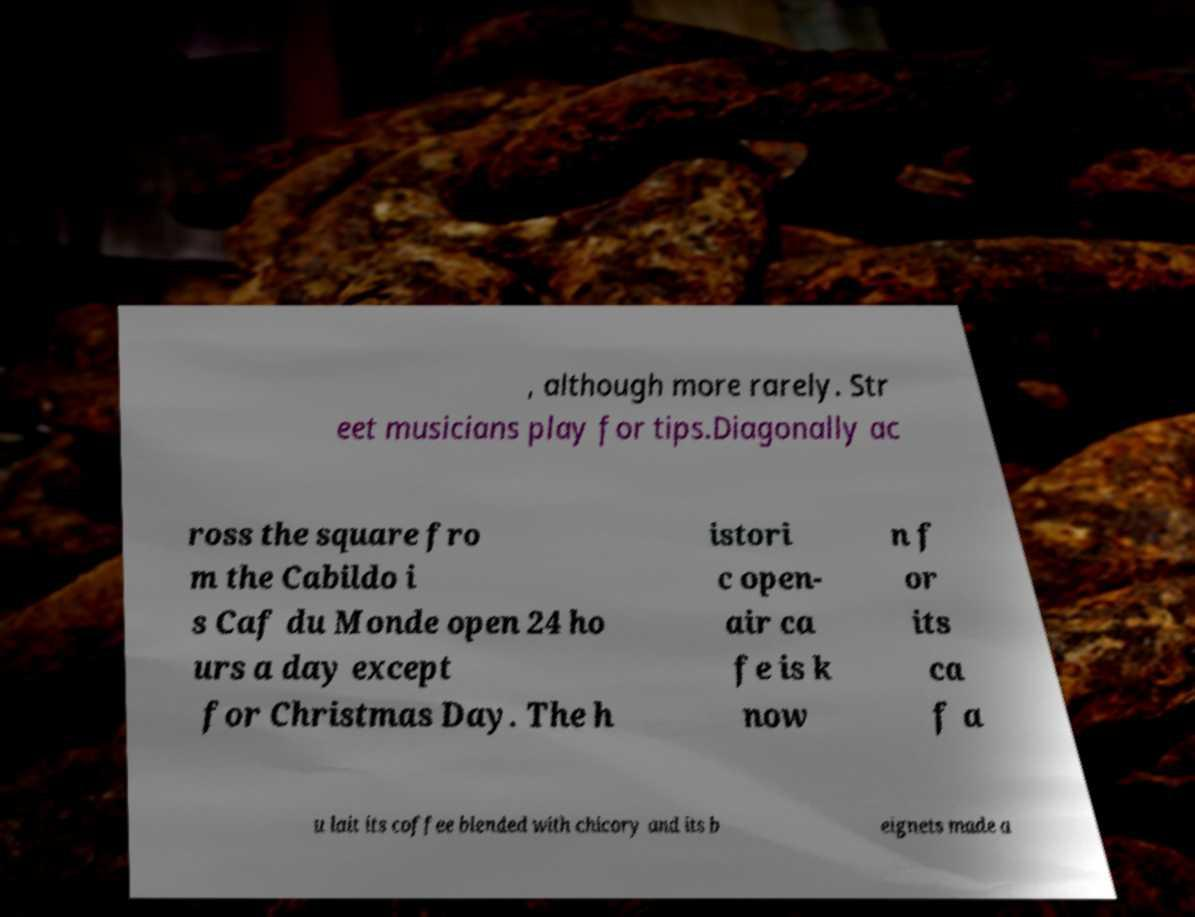I need the written content from this picture converted into text. Can you do that? , although more rarely. Str eet musicians play for tips.Diagonally ac ross the square fro m the Cabildo i s Caf du Monde open 24 ho urs a day except for Christmas Day. The h istori c open- air ca fe is k now n f or its ca f a u lait its coffee blended with chicory and its b eignets made a 